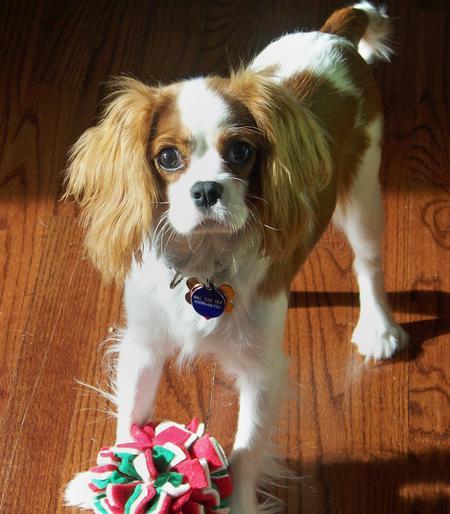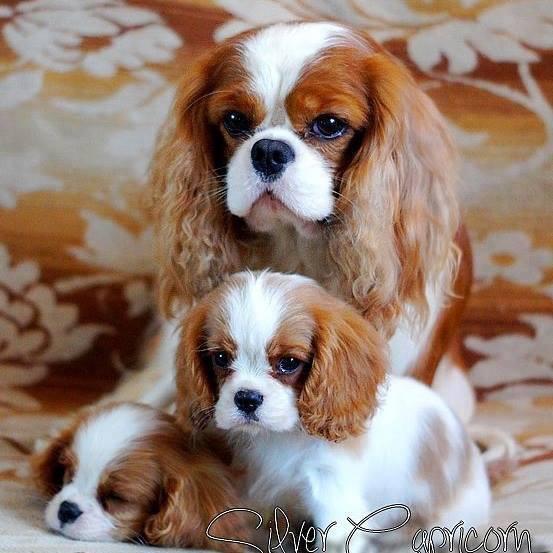The first image is the image on the left, the second image is the image on the right. Analyze the images presented: Is the assertion "An image contains at least two dogs." valid? Answer yes or no. Yes. The first image is the image on the left, the second image is the image on the right. Evaluate the accuracy of this statement regarding the images: "At least one King Charles puppy is shown next to their mother.". Is it true? Answer yes or no. Yes. 